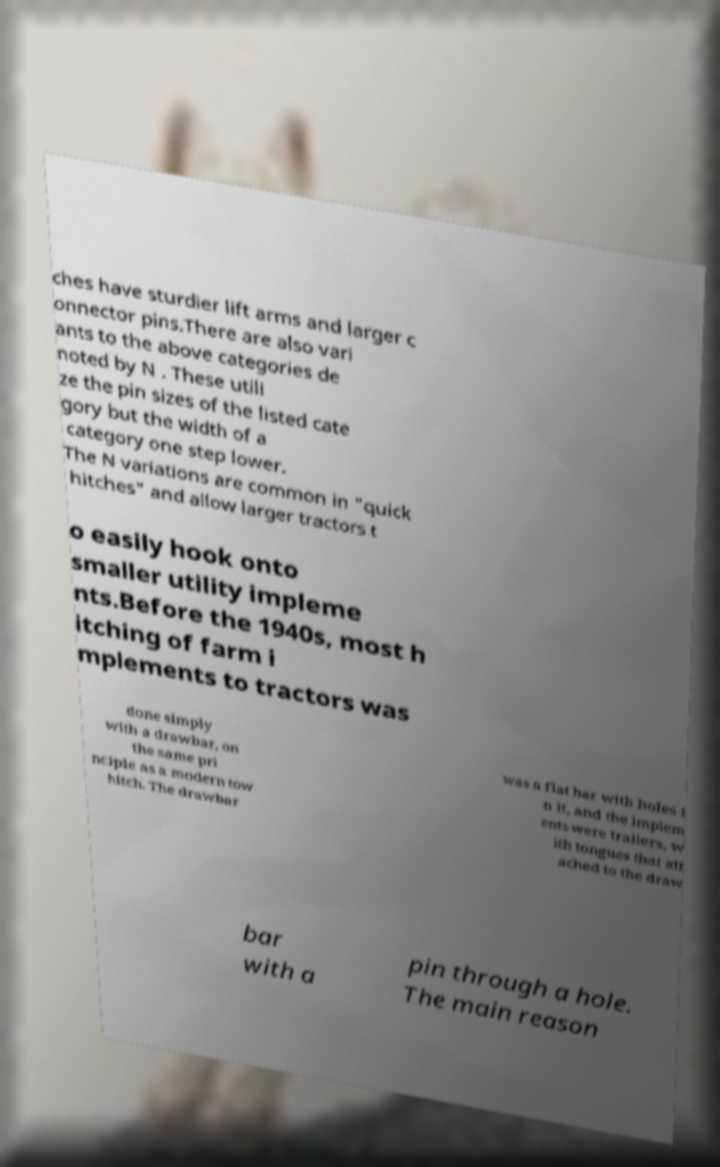For documentation purposes, I need the text within this image transcribed. Could you provide that? ches have sturdier lift arms and larger c onnector pins.There are also vari ants to the above categories de noted by N . These utili ze the pin sizes of the listed cate gory but the width of a category one step lower. The N variations are common in "quick hitches" and allow larger tractors t o easily hook onto smaller utility impleme nts.Before the 1940s, most h itching of farm i mplements to tractors was done simply with a drawbar, on the same pri nciple as a modern tow hitch. The drawbar was a flat bar with holes i n it, and the implem ents were trailers, w ith tongues that att ached to the draw bar with a pin through a hole. The main reason 